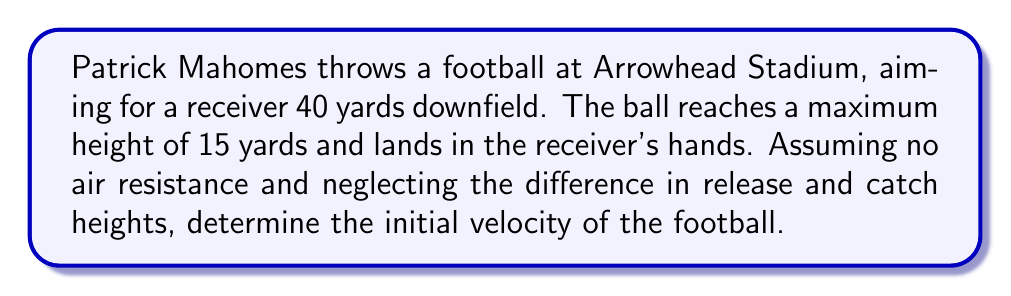Show me your answer to this math problem. Let's approach this step-by-step:

1) We can use the equations of projectile motion to solve this problem. The relevant equations are:

   $$x = v_0 \cos(\theta) t$$
   $$y = v_0 \sin(\theta) t - \frac{1}{2}gt^2$$

   Where $v_0$ is the initial velocity, $\theta$ is the launch angle, $g$ is the acceleration due to gravity (9.8 m/s²), $x$ is the horizontal distance, and $y$ is the vertical distance.

2) We know that $x = 40$ yards = 36.576 meters (1 yard = 0.9144 meters)
   The maximum height $y_{max} = 15$ yards = 13.716 meters

3) At the highest point, the vertical velocity is zero. We can use this to find the time to reach the highest point:

   $$v_0 \sin(\theta) - gt_{max} = 0$$
   $$t_{max} = \frac{v_0 \sin(\theta)}{g}$$

4) The total time of flight is twice this:

   $$t_{total} = \frac{2v_0 \sin(\theta)}{g}$$

5) We can use the equation for $x$ to find:

   $$36.576 = v_0 \cos(\theta) \frac{2v_0 \sin(\theta)}{g}$$

6) The maximum height is reached when:

   $$13.716 = \frac{v_0^2 \sin^2(\theta)}{2g}$$

7) Dividing these equations:

   $$\frac{36.576}{13.716} = \frac{2\cos(\theta)\sin(\theta)}{\sin^2(\theta)} = \frac{2}{\tan(\theta)}$$

8) Solving this:

   $$\tan(\theta) = \frac{2 * 13.716}{36.576} = 0.75$$
   $$\theta = \arctan(0.75) = 36.87°$$

9) Substituting this back into the equation for $y_{max}$:

   $$13.716 = \frac{v_0^2 \sin^2(36.87°)}{2 * 9.8}$$

10) Solving for $v_0$:

    $$v_0 = \sqrt{\frac{2 * 13.716 * 9.8}{\sin^2(36.87°)}} = 22.15 \text{ m/s}$$

11) Converting back to yards per second:

    $$22.15 \text{ m/s} * \frac{1.09361 \text{ yards}}{1 \text{ m}} = 24.22 \text{ yards/s}$$
Answer: 24.22 yards/s 